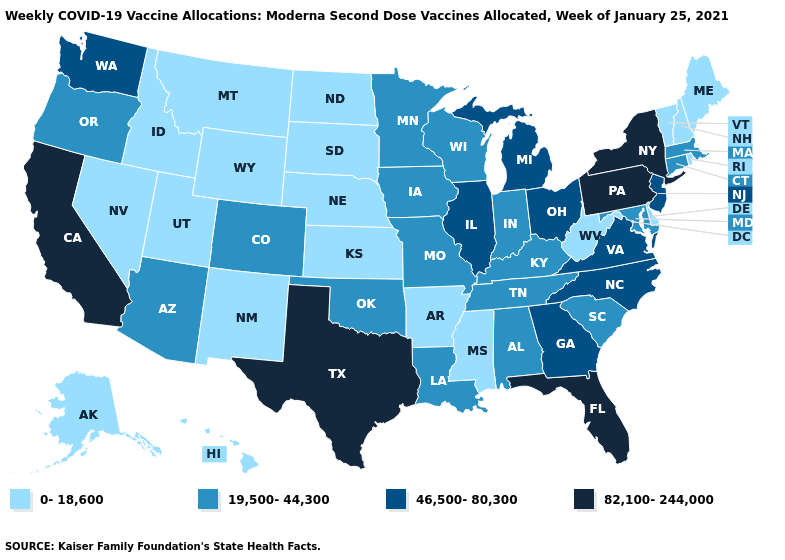Among the states that border Iowa , does Illinois have the highest value?
Answer briefly. Yes. Name the states that have a value in the range 19,500-44,300?
Answer briefly. Alabama, Arizona, Colorado, Connecticut, Indiana, Iowa, Kentucky, Louisiana, Maryland, Massachusetts, Minnesota, Missouri, Oklahoma, Oregon, South Carolina, Tennessee, Wisconsin. Which states have the lowest value in the Northeast?
Keep it brief. Maine, New Hampshire, Rhode Island, Vermont. What is the value of Florida?
Concise answer only. 82,100-244,000. What is the value of Virginia?
Be succinct. 46,500-80,300. Does California have the highest value in the West?
Answer briefly. Yes. What is the lowest value in the USA?
Short answer required. 0-18,600. Name the states that have a value in the range 0-18,600?
Write a very short answer. Alaska, Arkansas, Delaware, Hawaii, Idaho, Kansas, Maine, Mississippi, Montana, Nebraska, Nevada, New Hampshire, New Mexico, North Dakota, Rhode Island, South Dakota, Utah, Vermont, West Virginia, Wyoming. Name the states that have a value in the range 19,500-44,300?
Quick response, please. Alabama, Arizona, Colorado, Connecticut, Indiana, Iowa, Kentucky, Louisiana, Maryland, Massachusetts, Minnesota, Missouri, Oklahoma, Oregon, South Carolina, Tennessee, Wisconsin. Among the states that border Tennessee , which have the highest value?
Give a very brief answer. Georgia, North Carolina, Virginia. What is the lowest value in the MidWest?
Short answer required. 0-18,600. Name the states that have a value in the range 82,100-244,000?
Keep it brief. California, Florida, New York, Pennsylvania, Texas. Does the map have missing data?
Keep it brief. No. What is the value of West Virginia?
Short answer required. 0-18,600. Which states have the lowest value in the South?
Be succinct. Arkansas, Delaware, Mississippi, West Virginia. 